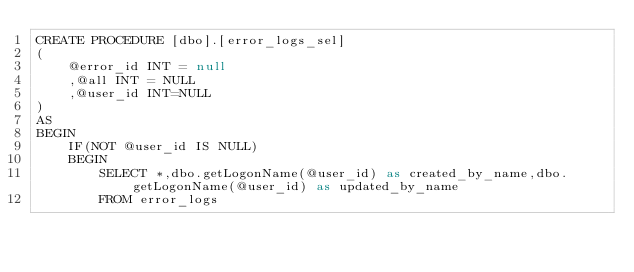Convert code to text. <code><loc_0><loc_0><loc_500><loc_500><_SQL_>CREATE PROCEDURE [dbo].[error_logs_sel]
(
    @error_id INT = null
    ,@all	INT = NULL
    ,@user_id INT=NULL
)
AS
BEGIN
    IF(NOT @user_id IS NULL)
    BEGIN
        SELECT *,dbo.getLogonName(@user_id) as created_by_name,dbo.getLogonName(@user_id) as updated_by_name
        FROM error_logs</code> 